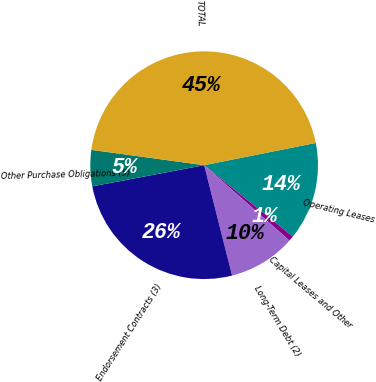Convert chart. <chart><loc_0><loc_0><loc_500><loc_500><pie_chart><fcel>Operating Leases<fcel>Capital Leases and Other<fcel>Long-Term Debt (2)<fcel>Endorsement Contracts (3)<fcel>Other Purchase Obligations (5)<fcel>TOTAL<nl><fcel>13.93%<fcel>0.73%<fcel>9.53%<fcel>25.97%<fcel>5.13%<fcel>44.72%<nl></chart> 